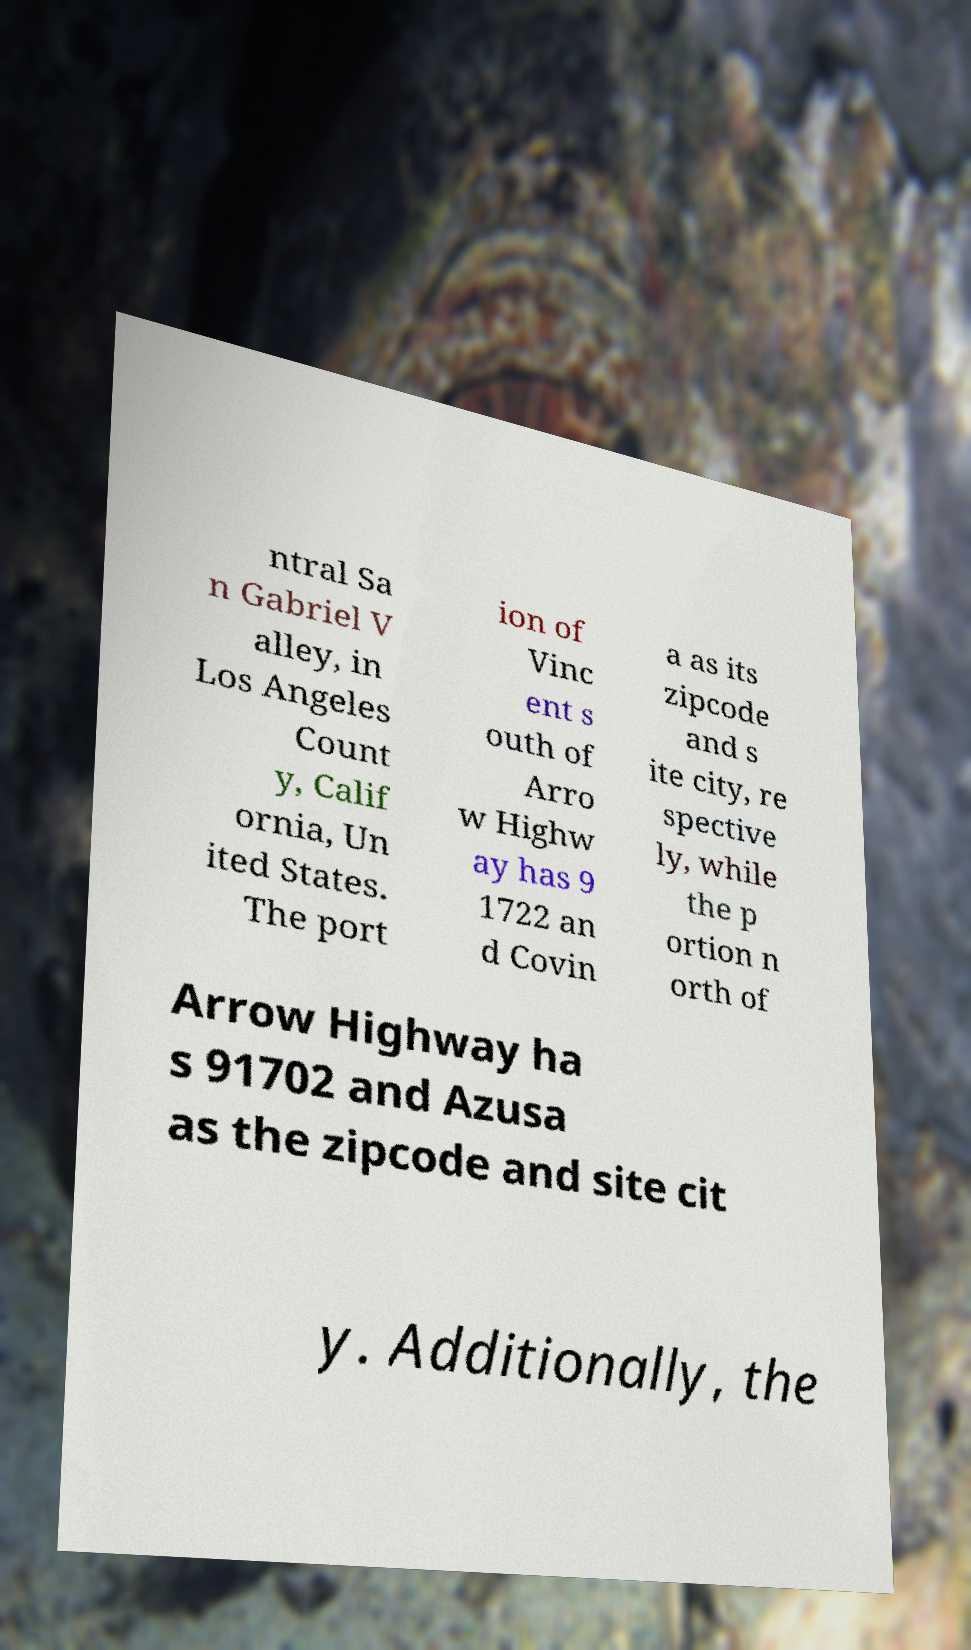Could you assist in decoding the text presented in this image and type it out clearly? ntral Sa n Gabriel V alley, in Los Angeles Count y, Calif ornia, Un ited States. The port ion of Vinc ent s outh of Arro w Highw ay has 9 1722 an d Covin a as its zipcode and s ite city, re spective ly, while the p ortion n orth of Arrow Highway ha s 91702 and Azusa as the zipcode and site cit y. Additionally, the 